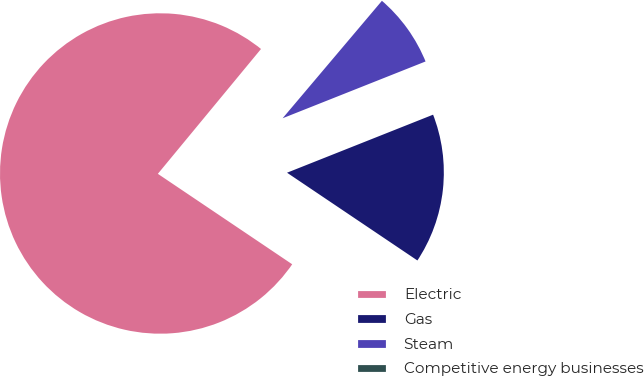Convert chart to OTSL. <chart><loc_0><loc_0><loc_500><loc_500><pie_chart><fcel>Electric<fcel>Gas<fcel>Steam<fcel>Competitive energy businesses<nl><fcel>76.56%<fcel>15.45%<fcel>7.81%<fcel>0.18%<nl></chart> 